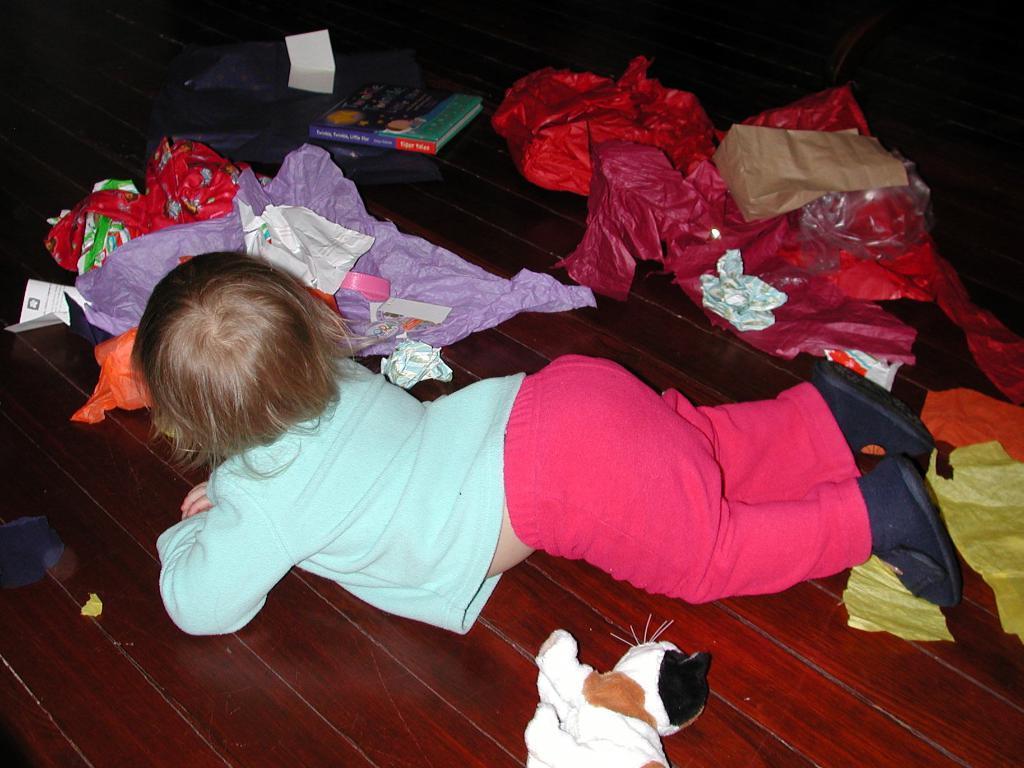How would you summarize this image in a sentence or two? This picture is clicked inside. In the center there is a kid wearing blue color t-shirt and lying on the wooden object and we can see there are some items placed on the top of the wooden table. 